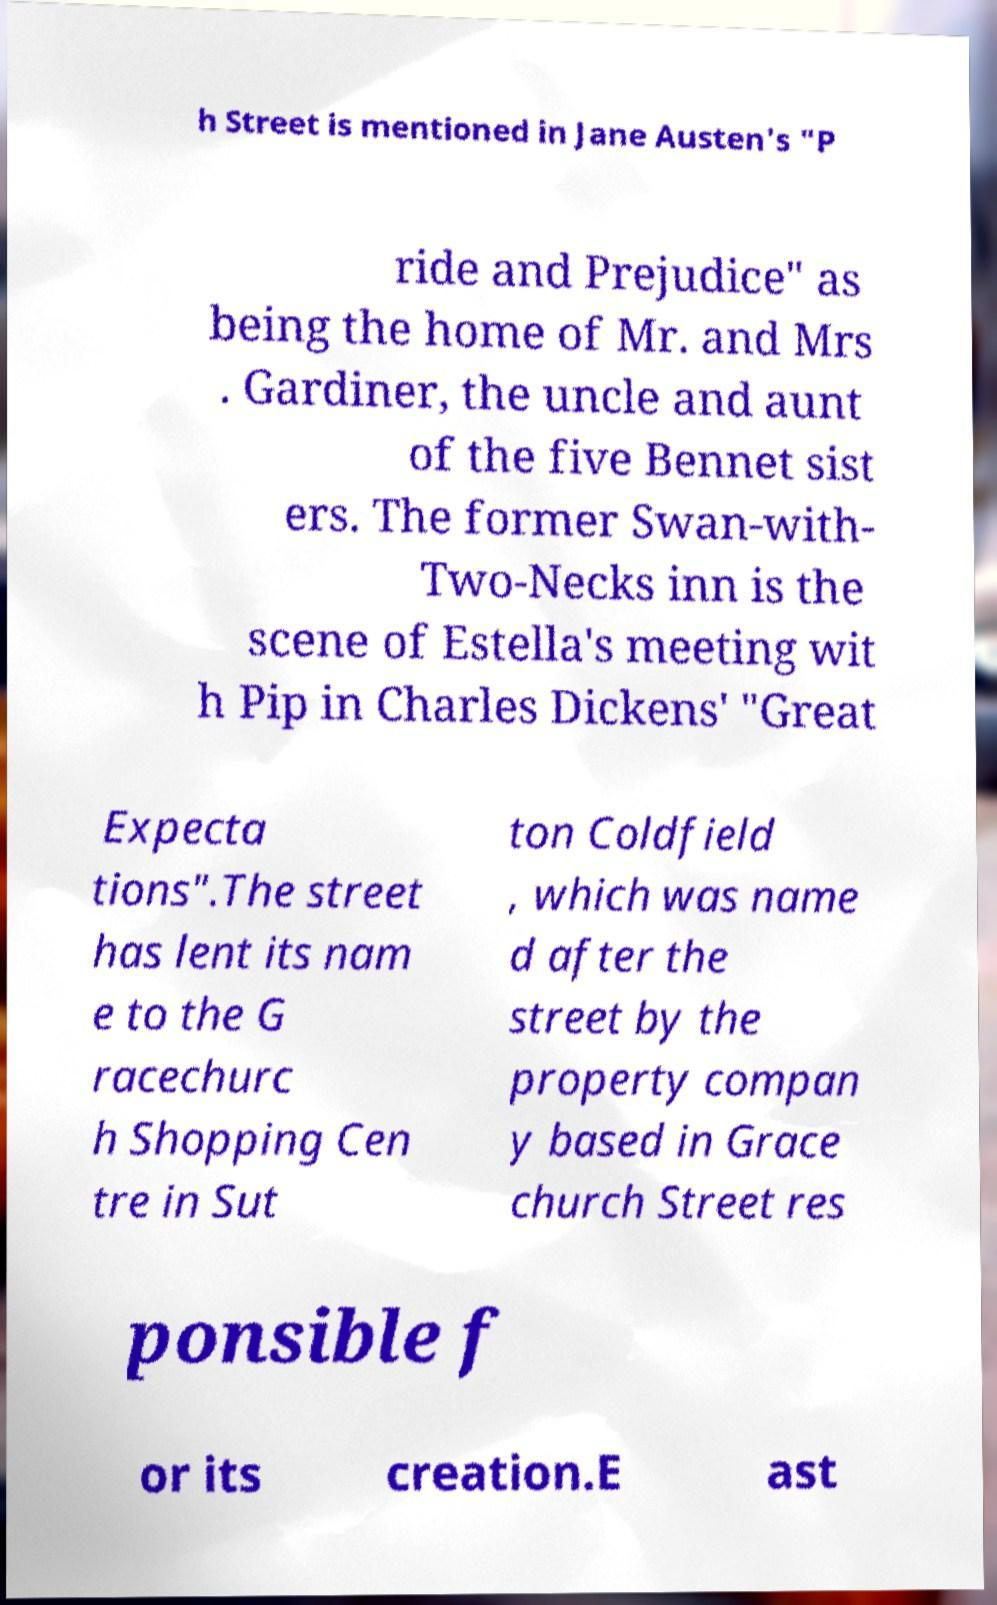Please read and relay the text visible in this image. What does it say? h Street is mentioned in Jane Austen's "P ride and Prejudice" as being the home of Mr. and Mrs . Gardiner, the uncle and aunt of the five Bennet sist ers. The former Swan-with- Two-Necks inn is the scene of Estella's meeting wit h Pip in Charles Dickens' "Great Expecta tions".The street has lent its nam e to the G racechurc h Shopping Cen tre in Sut ton Coldfield , which was name d after the street by the property compan y based in Grace church Street res ponsible f or its creation.E ast 